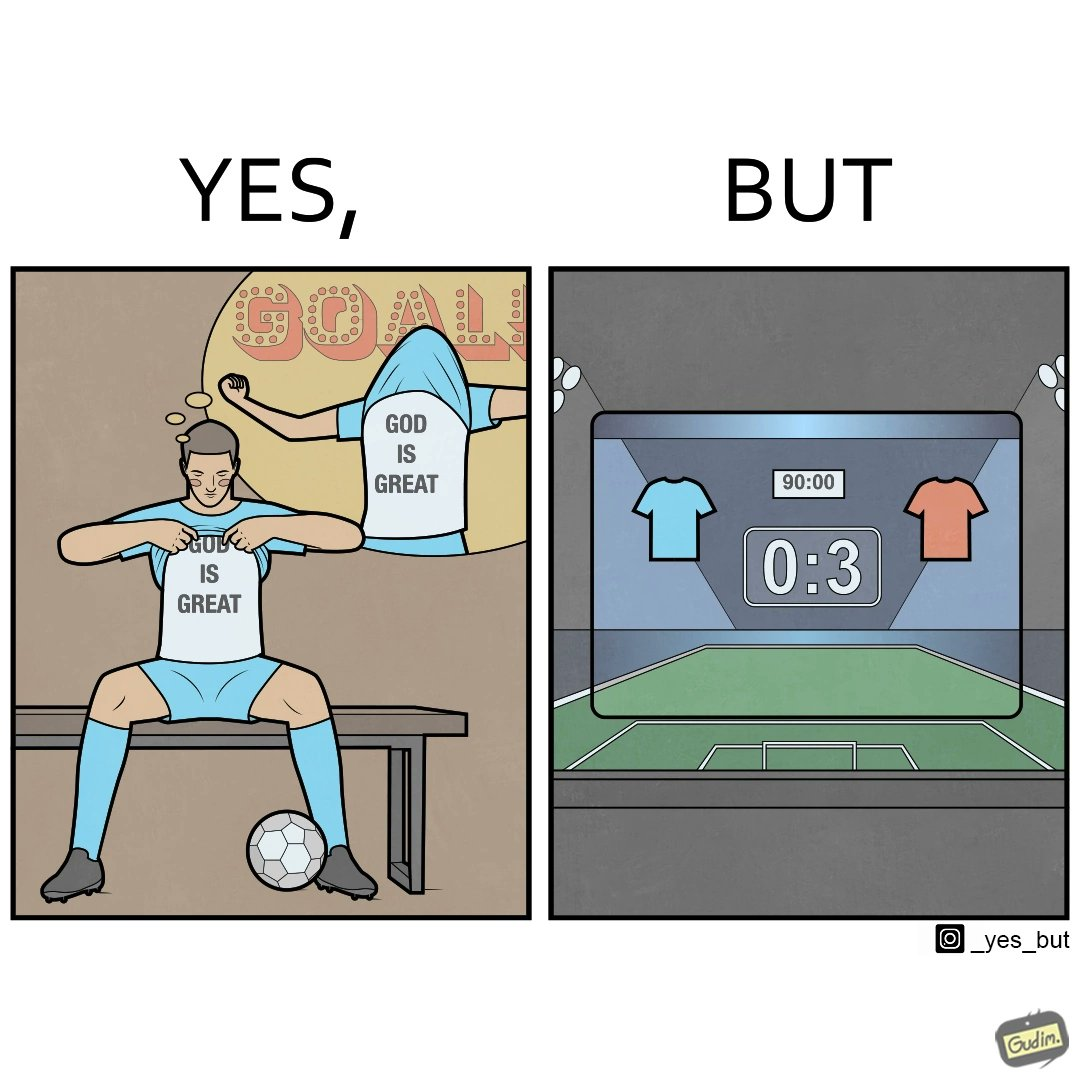What do you see in each half of this image? In the left part of the image: The image shows a football player wearing a t-shirt under his blue jersey that says "GOD IS GREAT". The player is thinking that he will celebrate by showing the inner t-shirt with the text when he scores a goal. In the right part of the image: The image shows the results of a football match after the 90 minutes are over. It shows that the team wearing the red jersey scored 3 goals whereas the team with blue jersey scored 0 goals. The red team has won the match. 